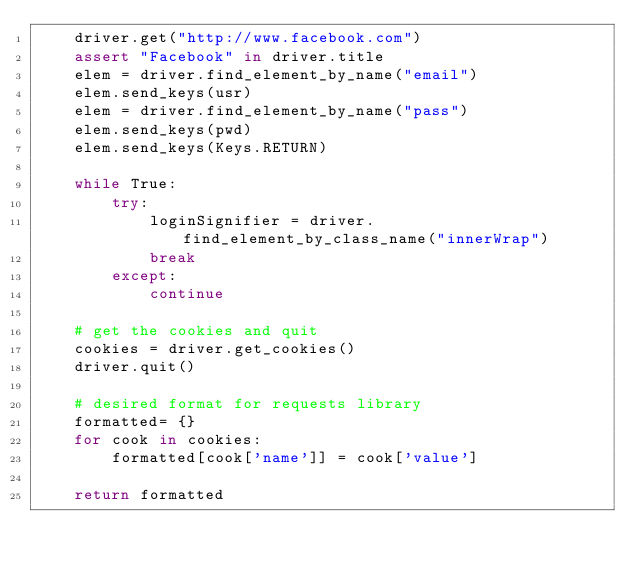<code> <loc_0><loc_0><loc_500><loc_500><_Python_>    driver.get("http://www.facebook.com")
    assert "Facebook" in driver.title
    elem = driver.find_element_by_name("email")
    elem.send_keys(usr)
    elem = driver.find_element_by_name("pass")
    elem.send_keys(pwd)
    elem.send_keys(Keys.RETURN)
  
    while True:
        try:
            loginSignifier = driver.find_element_by_class_name("innerWrap")
            break
        except:
            continue

    # get the cookies and quit
    cookies = driver.get_cookies()
    driver.quit()

    # desired format for requests library
    formatted= {}
    for cook in cookies:
        formatted[cook['name']] = cook['value']

    return formatted
</code> 